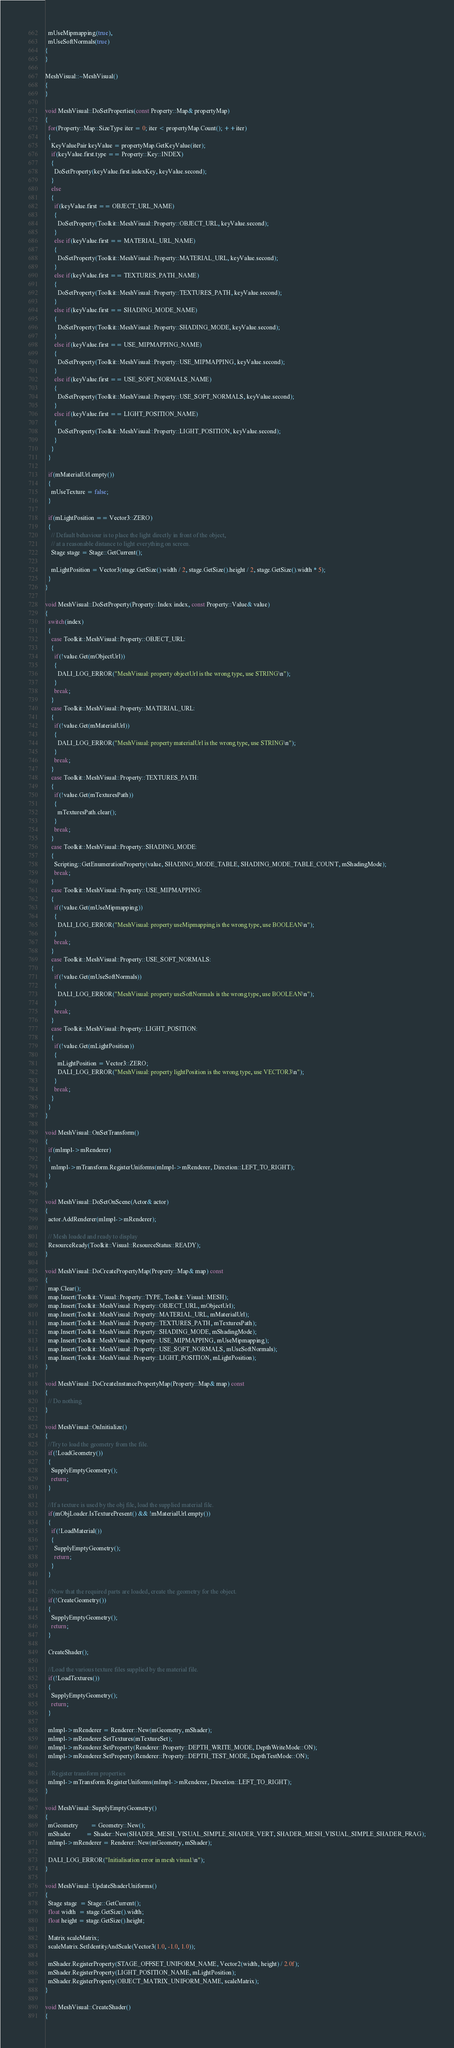Convert code to text. <code><loc_0><loc_0><loc_500><loc_500><_C++_>  mUseMipmapping(true),
  mUseSoftNormals(true)
{
}

MeshVisual::~MeshVisual()
{
}

void MeshVisual::DoSetProperties(const Property::Map& propertyMap)
{
  for(Property::Map::SizeType iter = 0; iter < propertyMap.Count(); ++iter)
  {
    KeyValuePair keyValue = propertyMap.GetKeyValue(iter);
    if(keyValue.first.type == Property::Key::INDEX)
    {
      DoSetProperty(keyValue.first.indexKey, keyValue.second);
    }
    else
    {
      if(keyValue.first == OBJECT_URL_NAME)
      {
        DoSetProperty(Toolkit::MeshVisual::Property::OBJECT_URL, keyValue.second);
      }
      else if(keyValue.first == MATERIAL_URL_NAME)
      {
        DoSetProperty(Toolkit::MeshVisual::Property::MATERIAL_URL, keyValue.second);
      }
      else if(keyValue.first == TEXTURES_PATH_NAME)
      {
        DoSetProperty(Toolkit::MeshVisual::Property::TEXTURES_PATH, keyValue.second);
      }
      else if(keyValue.first == SHADING_MODE_NAME)
      {
        DoSetProperty(Toolkit::MeshVisual::Property::SHADING_MODE, keyValue.second);
      }
      else if(keyValue.first == USE_MIPMAPPING_NAME)
      {
        DoSetProperty(Toolkit::MeshVisual::Property::USE_MIPMAPPING, keyValue.second);
      }
      else if(keyValue.first == USE_SOFT_NORMALS_NAME)
      {
        DoSetProperty(Toolkit::MeshVisual::Property::USE_SOFT_NORMALS, keyValue.second);
      }
      else if(keyValue.first == LIGHT_POSITION_NAME)
      {
        DoSetProperty(Toolkit::MeshVisual::Property::LIGHT_POSITION, keyValue.second);
      }
    }
  }

  if(mMaterialUrl.empty())
  {
    mUseTexture = false;
  }

  if(mLightPosition == Vector3::ZERO)
  {
    // Default behaviour is to place the light directly in front of the object,
    // at a reasonable distance to light everything on screen.
    Stage stage = Stage::GetCurrent();

    mLightPosition = Vector3(stage.GetSize().width / 2, stage.GetSize().height / 2, stage.GetSize().width * 5);
  }
}

void MeshVisual::DoSetProperty(Property::Index index, const Property::Value& value)
{
  switch(index)
  {
    case Toolkit::MeshVisual::Property::OBJECT_URL:
    {
      if(!value.Get(mObjectUrl))
      {
        DALI_LOG_ERROR("MeshVisual: property objectUrl is the wrong type, use STRING\n");
      }
      break;
    }
    case Toolkit::MeshVisual::Property::MATERIAL_URL:
    {
      if(!value.Get(mMaterialUrl))
      {
        DALI_LOG_ERROR("MeshVisual: property materialUrl is the wrong type, use STRING\n");
      }
      break;
    }
    case Toolkit::MeshVisual::Property::TEXTURES_PATH:
    {
      if(!value.Get(mTexturesPath))
      {
        mTexturesPath.clear();
      }
      break;
    }
    case Toolkit::MeshVisual::Property::SHADING_MODE:
    {
      Scripting::GetEnumerationProperty(value, SHADING_MODE_TABLE, SHADING_MODE_TABLE_COUNT, mShadingMode);
      break;
    }
    case Toolkit::MeshVisual::Property::USE_MIPMAPPING:
    {
      if(!value.Get(mUseMipmapping))
      {
        DALI_LOG_ERROR("MeshVisual: property useMipmapping is the wrong type, use BOOLEAN\n");
      }
      break;
    }
    case Toolkit::MeshVisual::Property::USE_SOFT_NORMALS:
    {
      if(!value.Get(mUseSoftNormals))
      {
        DALI_LOG_ERROR("MeshVisual: property useSoftNormals is the wrong type, use BOOLEAN\n");
      }
      break;
    }
    case Toolkit::MeshVisual::Property::LIGHT_POSITION:
    {
      if(!value.Get(mLightPosition))
      {
        mLightPosition = Vector3::ZERO;
        DALI_LOG_ERROR("MeshVisual: property lightPosition is the wrong type, use VECTOR3\n");
      }
      break;
    }
  }
}

void MeshVisual::OnSetTransform()
{
  if(mImpl->mRenderer)
  {
    mImpl->mTransform.RegisterUniforms(mImpl->mRenderer, Direction::LEFT_TO_RIGHT);
  }
}

void MeshVisual::DoSetOnScene(Actor& actor)
{
  actor.AddRenderer(mImpl->mRenderer);

  // Mesh loaded and ready to display
  ResourceReady(Toolkit::Visual::ResourceStatus::READY);
}

void MeshVisual::DoCreatePropertyMap(Property::Map& map) const
{
  map.Clear();
  map.Insert(Toolkit::Visual::Property::TYPE, Toolkit::Visual::MESH);
  map.Insert(Toolkit::MeshVisual::Property::OBJECT_URL, mObjectUrl);
  map.Insert(Toolkit::MeshVisual::Property::MATERIAL_URL, mMaterialUrl);
  map.Insert(Toolkit::MeshVisual::Property::TEXTURES_PATH, mTexturesPath);
  map.Insert(Toolkit::MeshVisual::Property::SHADING_MODE, mShadingMode);
  map.Insert(Toolkit::MeshVisual::Property::USE_MIPMAPPING, mUseMipmapping);
  map.Insert(Toolkit::MeshVisual::Property::USE_SOFT_NORMALS, mUseSoftNormals);
  map.Insert(Toolkit::MeshVisual::Property::LIGHT_POSITION, mLightPosition);
}

void MeshVisual::DoCreateInstancePropertyMap(Property::Map& map) const
{
  // Do nothing
}

void MeshVisual::OnInitialize()
{
  //Try to load the geometry from the file.
  if(!LoadGeometry())
  {
    SupplyEmptyGeometry();
    return;
  }

  //If a texture is used by the obj file, load the supplied material file.
  if(mObjLoader.IsTexturePresent() && !mMaterialUrl.empty())
  {
    if(!LoadMaterial())
    {
      SupplyEmptyGeometry();
      return;
    }
  }

  //Now that the required parts are loaded, create the geometry for the object.
  if(!CreateGeometry())
  {
    SupplyEmptyGeometry();
    return;
  }

  CreateShader();

  //Load the various texture files supplied by the material file.
  if(!LoadTextures())
  {
    SupplyEmptyGeometry();
    return;
  }

  mImpl->mRenderer = Renderer::New(mGeometry, mShader);
  mImpl->mRenderer.SetTextures(mTextureSet);
  mImpl->mRenderer.SetProperty(Renderer::Property::DEPTH_WRITE_MODE, DepthWriteMode::ON);
  mImpl->mRenderer.SetProperty(Renderer::Property::DEPTH_TEST_MODE, DepthTestMode::ON);

  //Register transform properties
  mImpl->mTransform.RegisterUniforms(mImpl->mRenderer, Direction::LEFT_TO_RIGHT);
}

void MeshVisual::SupplyEmptyGeometry()
{
  mGeometry        = Geometry::New();
  mShader          = Shader::New(SHADER_MESH_VISUAL_SIMPLE_SHADER_VERT, SHADER_MESH_VISUAL_SIMPLE_SHADER_FRAG);
  mImpl->mRenderer = Renderer::New(mGeometry, mShader);

  DALI_LOG_ERROR("Initialisation error in mesh visual.\n");
}

void MeshVisual::UpdateShaderUniforms()
{
  Stage stage  = Stage::GetCurrent();
  float width  = stage.GetSize().width;
  float height = stage.GetSize().height;

  Matrix scaleMatrix;
  scaleMatrix.SetIdentityAndScale(Vector3(1.0, -1.0, 1.0));

  mShader.RegisterProperty(STAGE_OFFSET_UNIFORM_NAME, Vector2(width, height) / 2.0f);
  mShader.RegisterProperty(LIGHT_POSITION_NAME, mLightPosition);
  mShader.RegisterProperty(OBJECT_MATRIX_UNIFORM_NAME, scaleMatrix);
}

void MeshVisual::CreateShader()
{</code> 